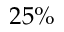Convert formula to latex. <formula><loc_0><loc_0><loc_500><loc_500>2 5 \%</formula> 